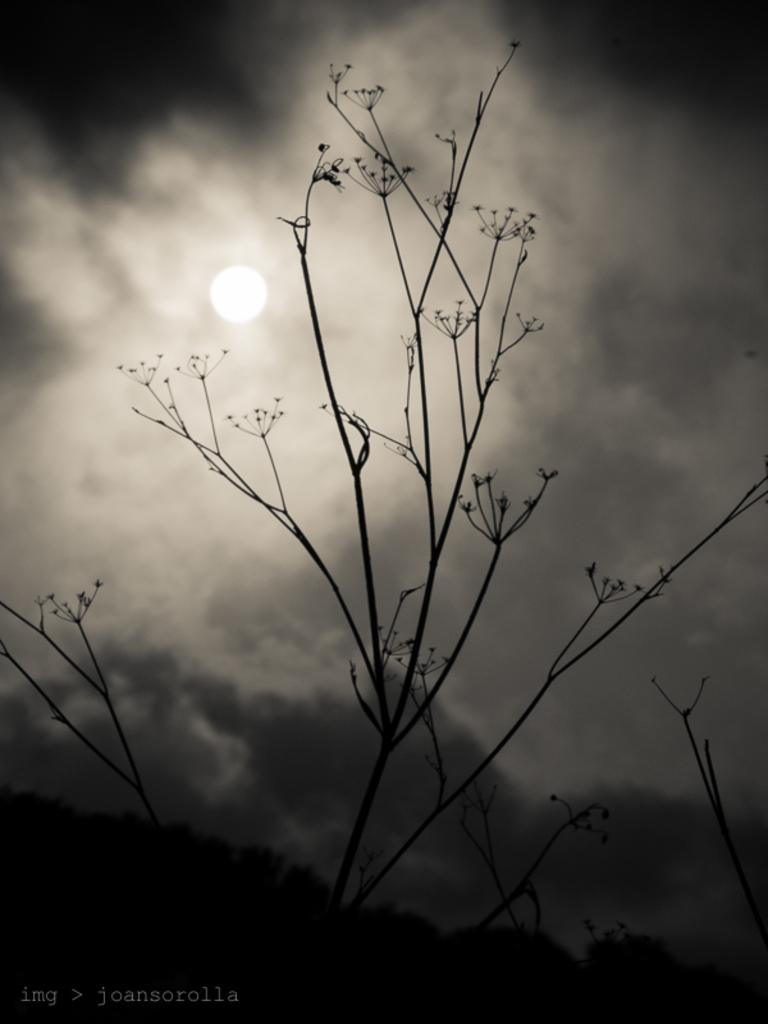What type of living organisms can be seen in the image? Plants can be seen in the image. What can be seen in the sky in the image? Clouds are visible in the sky in the image. What celestial body is observable in the image? The moon is observable in the image. What type of acoustics can be heard from the table in the image? There is no table present in the image, and therefore no acoustics can be heard from it. 